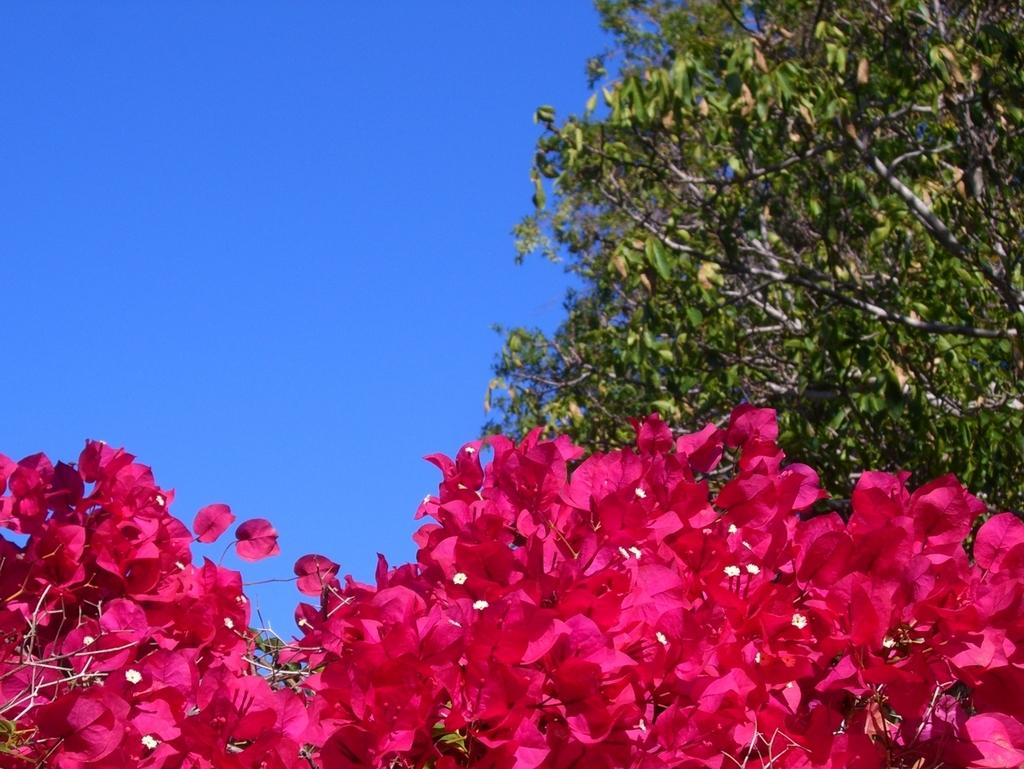What type of vegetation can be seen in the image? There are trees and flowers in the image. What can be seen in the background of the image? The sky is visible in the background of the image. What type of plastic material can be seen in the image? There is no plastic material present in the image. What scent can be detected from the flowers in the image? The image does not provide information about the scent of the flowers, so it cannot be determined from the image. 